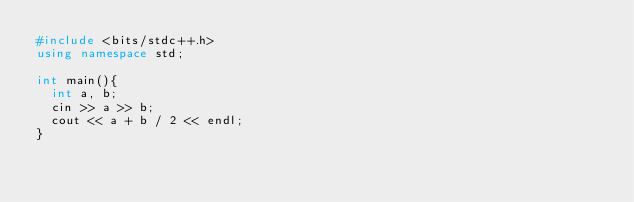<code> <loc_0><loc_0><loc_500><loc_500><_C++_>#include <bits/stdc++.h>
using namespace std;

int main(){
  int a, b;
  cin >> a >> b;
  cout << a + b / 2 << endl;
}</code> 